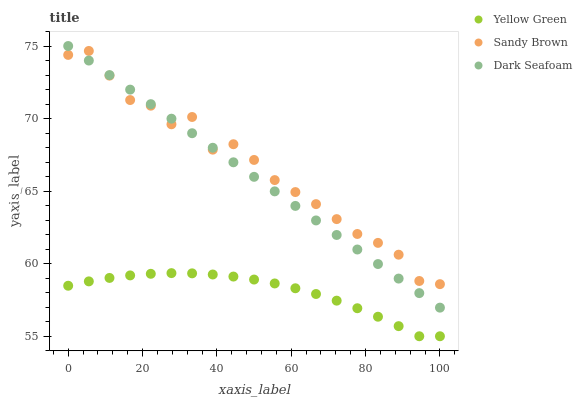Does Yellow Green have the minimum area under the curve?
Answer yes or no. Yes. Does Sandy Brown have the maximum area under the curve?
Answer yes or no. Yes. Does Sandy Brown have the minimum area under the curve?
Answer yes or no. No. Does Yellow Green have the maximum area under the curve?
Answer yes or no. No. Is Dark Seafoam the smoothest?
Answer yes or no. Yes. Is Sandy Brown the roughest?
Answer yes or no. Yes. Is Yellow Green the smoothest?
Answer yes or no. No. Is Yellow Green the roughest?
Answer yes or no. No. Does Yellow Green have the lowest value?
Answer yes or no. Yes. Does Sandy Brown have the lowest value?
Answer yes or no. No. Does Dark Seafoam have the highest value?
Answer yes or no. Yes. Does Sandy Brown have the highest value?
Answer yes or no. No. Is Yellow Green less than Sandy Brown?
Answer yes or no. Yes. Is Sandy Brown greater than Yellow Green?
Answer yes or no. Yes. Does Sandy Brown intersect Dark Seafoam?
Answer yes or no. Yes. Is Sandy Brown less than Dark Seafoam?
Answer yes or no. No. Is Sandy Brown greater than Dark Seafoam?
Answer yes or no. No. Does Yellow Green intersect Sandy Brown?
Answer yes or no. No. 